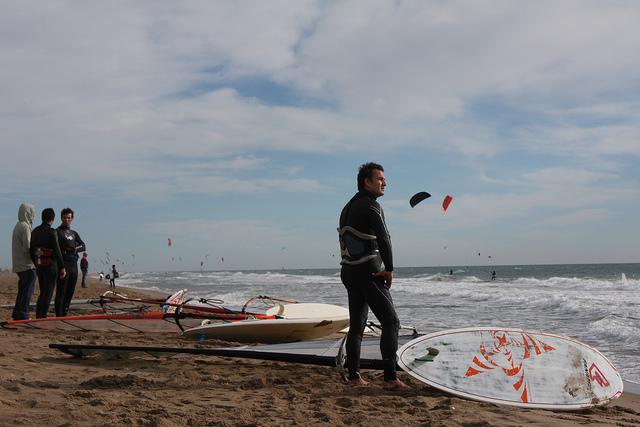What is the man standing on?
Be succinct. Sand. Are these men on a boat?
Answer briefly. No. What color is the man's skin?
Short answer required. White. What are these men standing in front of?
Keep it brief. Ocean. What is the temperature outside?
Keep it brief. Cold. Are the boys happy?
Be succinct. Yes. Is the man in the forefront trying to get signal on a cell phone?
Answer briefly. No. What is this person standing on?
Short answer required. Sand. Were people moving when this picture was taken?
Answer briefly. No. What is lying on the ground?
Concise answer only. Surfboard. What is flying in the air?
Give a very brief answer. Kites. What brand of shoes is the skateboarder wearing?
Quick response, please. None. Was this photo taken recently?
Be succinct. Yes. Is this  a beach?
Quick response, please. Yes. Is the guy making a performance?
Answer briefly. No. Is he doing a trick?
Short answer required. No. Is the man in the foreground barefooted?
Short answer required. Yes. Is this busy metropolis?
Keep it brief. No. What is the man on a skateboard?
Be succinct. No. Which man is controlling the kite?
Answer briefly. No. Are there waves in the picture?
Concise answer only. Yes. What type of clouds are visible in this photo?
Give a very brief answer. Cumulus. What is the man doing?
Short answer required. Surfing. Is the person on the right male or female?
Keep it brief. Male. What object is painted on the surfboard?
Keep it brief. Star. What color is the shirt of the man standing?
Keep it brief. Black. What color is the board?
Be succinct. White. 